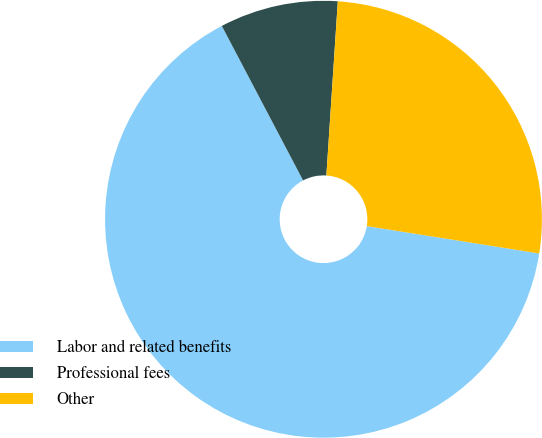Convert chart to OTSL. <chart><loc_0><loc_0><loc_500><loc_500><pie_chart><fcel>Labor and related benefits<fcel>Professional fees<fcel>Other<nl><fcel>64.79%<fcel>8.75%<fcel>26.46%<nl></chart> 